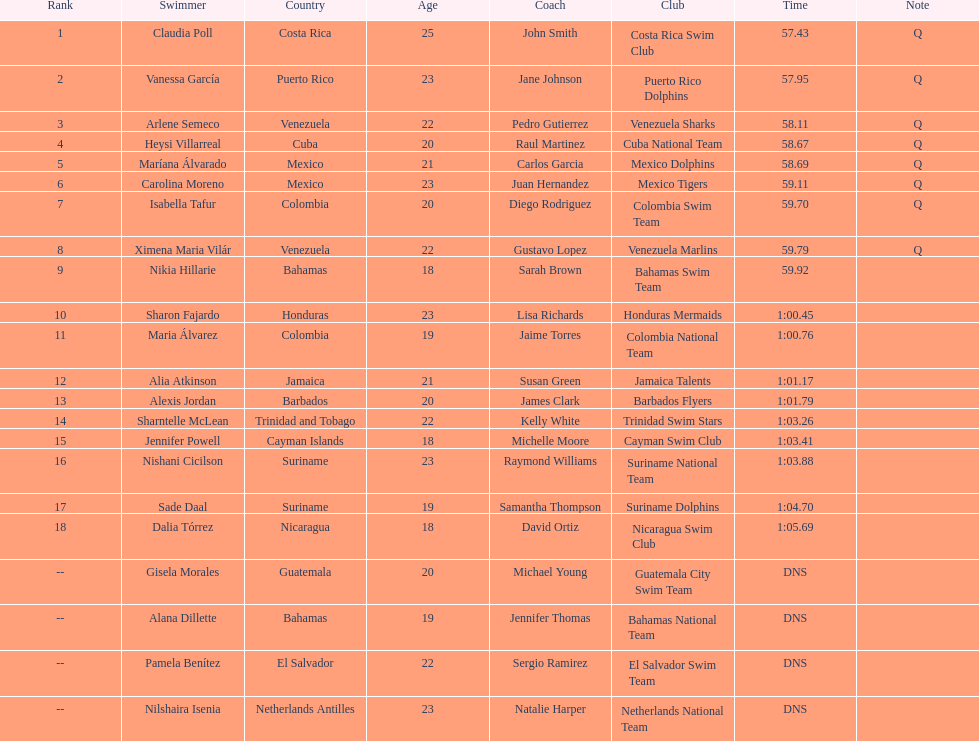How many competitors did not start the preliminaries? 4. 